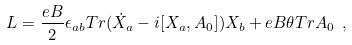Convert formula to latex. <formula><loc_0><loc_0><loc_500><loc_500>L = \frac { e B } { 2 } \epsilon _ { a b } T r ( \dot { X } _ { a } - i [ X _ { a } , A _ { 0 } ] ) X _ { b } + e B \theta T r A _ { 0 } \ ,</formula> 